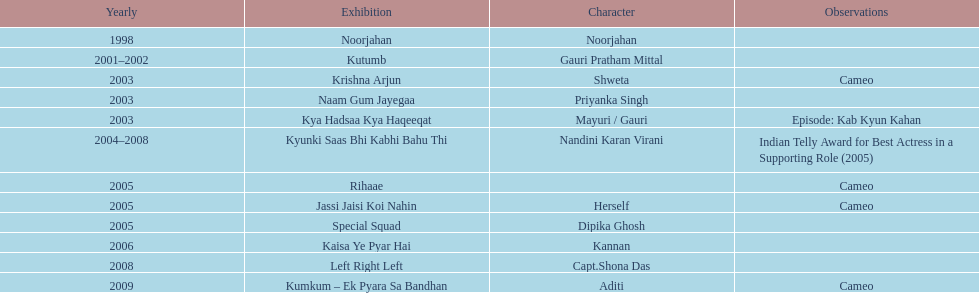How many different tv shows was gauri tejwani in before 2000? 1. 